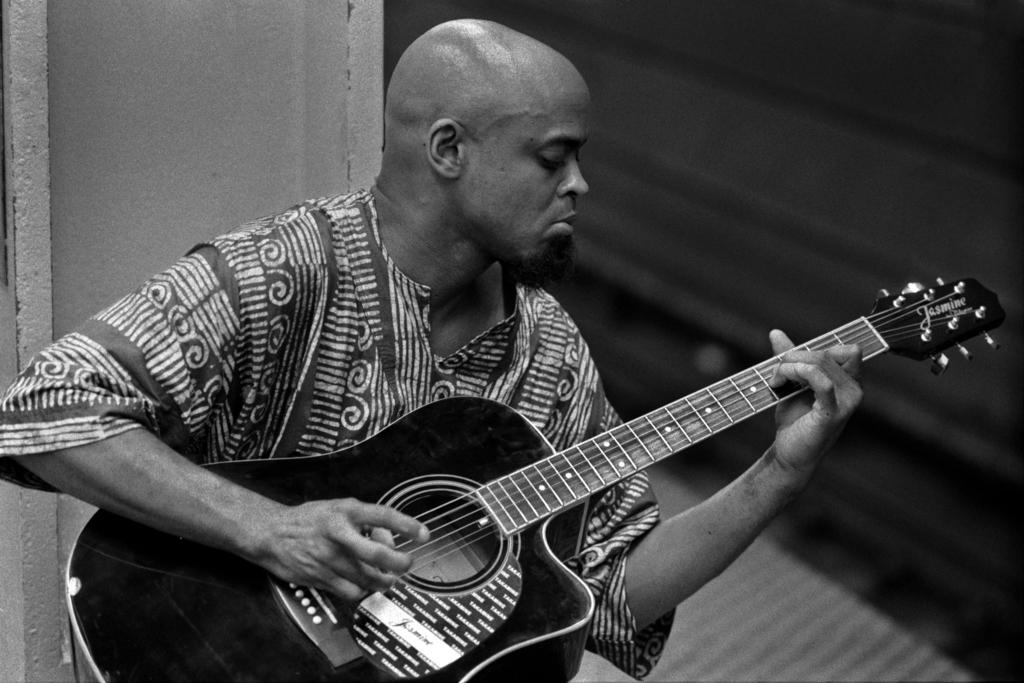What is the main subject of the image? There is a person in the image. What is the person doing in the image? The person is sitting and playing a guitar. What type of bulb is being used to light up the room in the image? There is no mention of a bulb or lighting in the image; it only shows a person sitting and playing a guitar. 